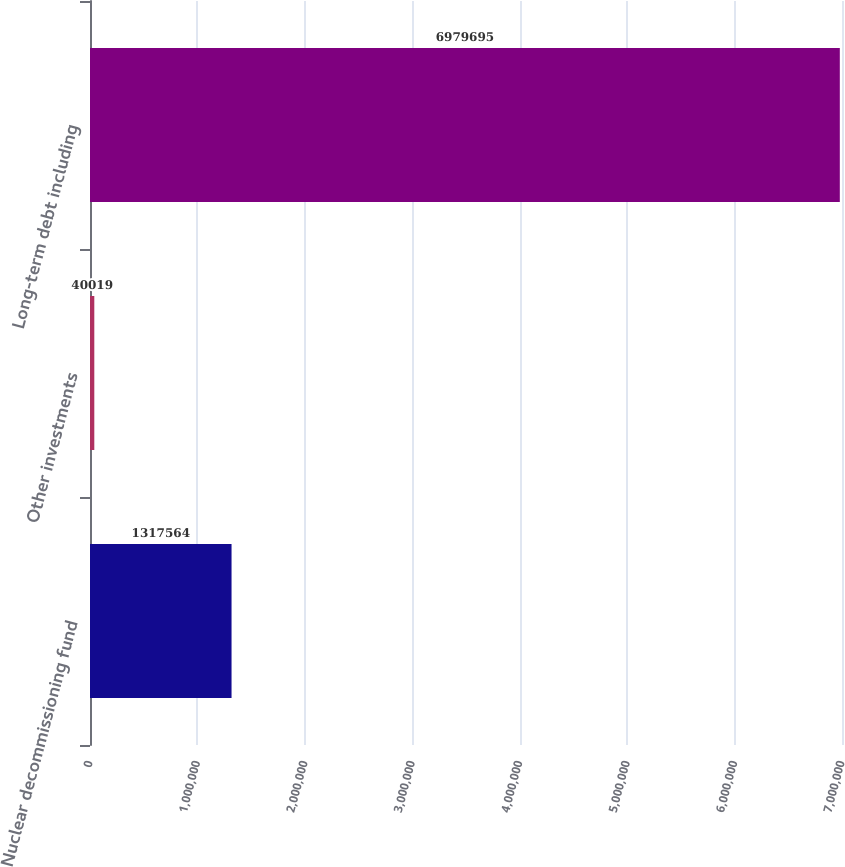<chart> <loc_0><loc_0><loc_500><loc_500><bar_chart><fcel>Nuclear decommissioning fund<fcel>Other investments<fcel>Long-term debt including<nl><fcel>1.31756e+06<fcel>40019<fcel>6.9797e+06<nl></chart> 